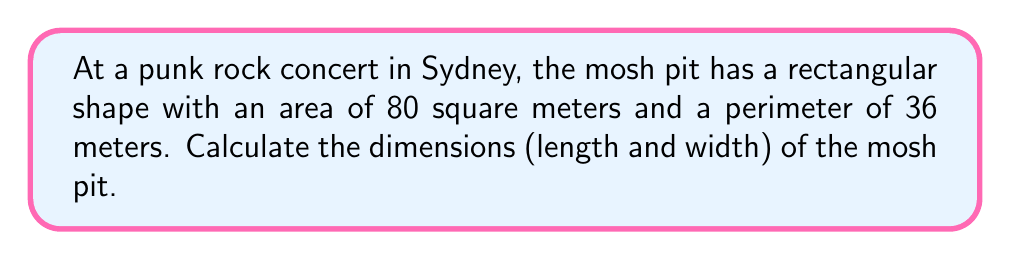Help me with this question. Let's approach this step-by-step:

1) Let $l$ be the length and $w$ be the width of the rectangular mosh pit.

2) Given information:
   Area = $80$ m²
   Perimeter = $36$ m

3) We can form two equations:
   Area equation: $lw = 80$ (1)
   Perimeter equation: $2l + 2w = 36$ (2)

4) From equation (2), we can express $l$ in terms of $w$:
   $2l + 2w = 36$
   $2l = 36 - 2w$
   $l = 18 - w$ (3)

5) Substitute (3) into equation (1):
   $(18 - w)w = 80$
   $18w - w² = 80$
   $w² - 18w + 80 = 0$

6) This is a quadratic equation. We can solve it using the quadratic formula:
   $w = \frac{-b \pm \sqrt{b² - 4ac}}{2a}$
   
   Where $a = 1$, $b = -18$, and $c = 80$

7) Solving:
   $w = \frac{18 \pm \sqrt{324 - 320}}{2} = \frac{18 \pm 2}{2}$

8) This gives us two solutions:
   $w = 10$ or $w = 8$

9) If $w = 10$, then $l = 18 - 10 = 8$
   If $w = 8$, then $l = 18 - 8 = 10$

10) Both solutions are valid. The mosh pit dimensions are either 10m x 8m or 8m x 10m.
Answer: 10 m × 8 m 